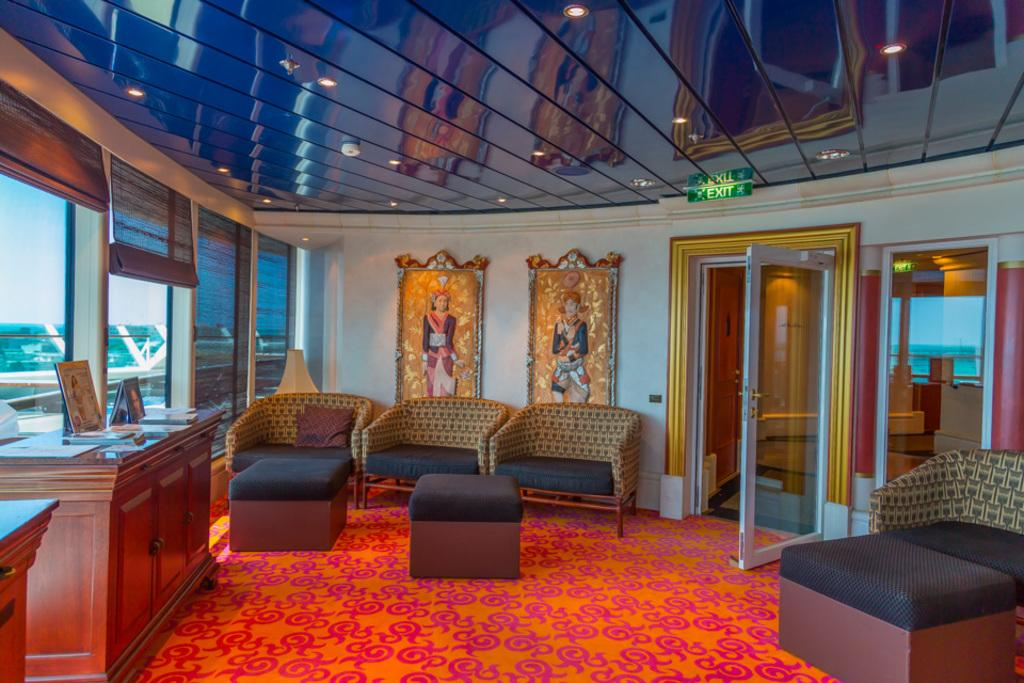What type of furniture is present in the image? There is a couch in the image. What can be seen on the couch? There are pillows on the couch. What is attached to the wall in the image? There are frames attached to the wall. What type of decorative items are present in the image? There are sculptures in the image. What is the purpose of the door in the image? The door provides access to another room or area. What is the purpose of the exit board in the image? The exit board provides information on the location of emergency exits. What type of lighting is present in the image? There are ceiling lights in the image. What type of storage furniture is present in the image? There is a cupboard in the image. What type of wall decoration is present in the image? There is a frame in the image. What type of floor covering is present in the image? There is a carpet in the image. How does the zinc jump in the image? There is no zinc present in the image, and therefore no such activity can be observed. 